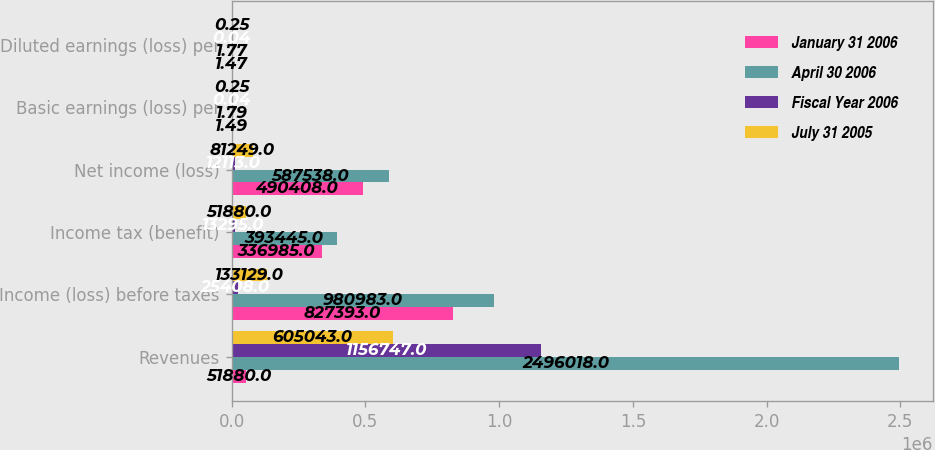Convert chart. <chart><loc_0><loc_0><loc_500><loc_500><stacked_bar_chart><ecel><fcel>Revenues<fcel>Income (loss) before taxes<fcel>Income tax (benefit)<fcel>Net income (loss)<fcel>Basic earnings (loss) per<fcel>Diluted earnings (loss) per<nl><fcel>January 31 2006<fcel>51880<fcel>827393<fcel>336985<fcel>490408<fcel>1.49<fcel>1.47<nl><fcel>April 30 2006<fcel>2.49602e+06<fcel>980983<fcel>393445<fcel>587538<fcel>1.79<fcel>1.77<nl><fcel>Fiscal Year 2006<fcel>1.15675e+06<fcel>25408<fcel>13295<fcel>12113<fcel>0.04<fcel>0.04<nl><fcel>July 31 2005<fcel>605043<fcel>133129<fcel>51880<fcel>81249<fcel>0.25<fcel>0.25<nl></chart> 